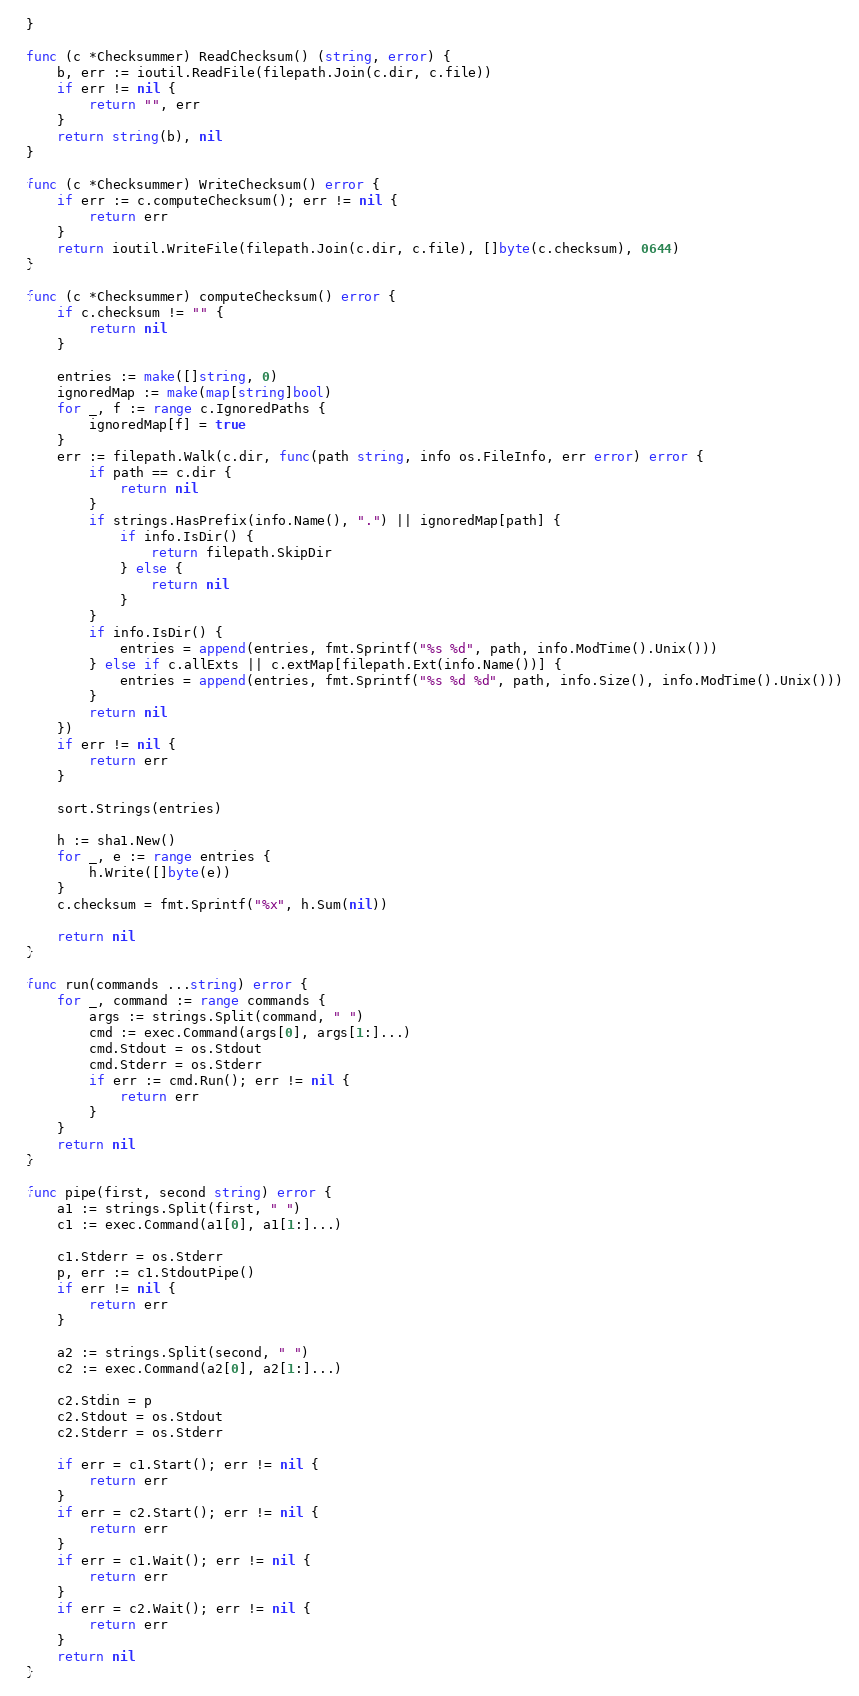Convert code to text. <code><loc_0><loc_0><loc_500><loc_500><_Go_>}

func (c *Checksummer) ReadChecksum() (string, error) {
	b, err := ioutil.ReadFile(filepath.Join(c.dir, c.file))
	if err != nil {
		return "", err
	}
	return string(b), nil
}

func (c *Checksummer) WriteChecksum() error {
	if err := c.computeChecksum(); err != nil {
		return err
	}
	return ioutil.WriteFile(filepath.Join(c.dir, c.file), []byte(c.checksum), 0644)
}

func (c *Checksummer) computeChecksum() error {
	if c.checksum != "" {
		return nil
	}

	entries := make([]string, 0)
	ignoredMap := make(map[string]bool)
	for _, f := range c.IgnoredPaths {
		ignoredMap[f] = true
	}
	err := filepath.Walk(c.dir, func(path string, info os.FileInfo, err error) error {
		if path == c.dir {
			return nil
		}
		if strings.HasPrefix(info.Name(), ".") || ignoredMap[path] {
			if info.IsDir() {
				return filepath.SkipDir
			} else {
				return nil
			}
		}
		if info.IsDir() {
			entries = append(entries, fmt.Sprintf("%s %d", path, info.ModTime().Unix()))
		} else if c.allExts || c.extMap[filepath.Ext(info.Name())] {
			entries = append(entries, fmt.Sprintf("%s %d %d", path, info.Size(), info.ModTime().Unix()))
		}
		return nil
	})
	if err != nil {
		return err
	}

	sort.Strings(entries)

	h := sha1.New()
	for _, e := range entries {
		h.Write([]byte(e))
	}
	c.checksum = fmt.Sprintf("%x", h.Sum(nil))

	return nil
}

func run(commands ...string) error {
	for _, command := range commands {
		args := strings.Split(command, " ")
		cmd := exec.Command(args[0], args[1:]...)
		cmd.Stdout = os.Stdout
		cmd.Stderr = os.Stderr
		if err := cmd.Run(); err != nil {
			return err
		}
	}
	return nil
}

func pipe(first, second string) error {
	a1 := strings.Split(first, " ")
	c1 := exec.Command(a1[0], a1[1:]...)

	c1.Stderr = os.Stderr
	p, err := c1.StdoutPipe()
	if err != nil {
		return err
	}

	a2 := strings.Split(second, " ")
	c2 := exec.Command(a2[0], a2[1:]...)

	c2.Stdin = p
	c2.Stdout = os.Stdout
	c2.Stderr = os.Stderr

	if err = c1.Start(); err != nil {
		return err
	}
	if err = c2.Start(); err != nil {
		return err
	}
	if err = c1.Wait(); err != nil {
		return err
	}
	if err = c2.Wait(); err != nil {
		return err
	}
	return nil
}
</code> 